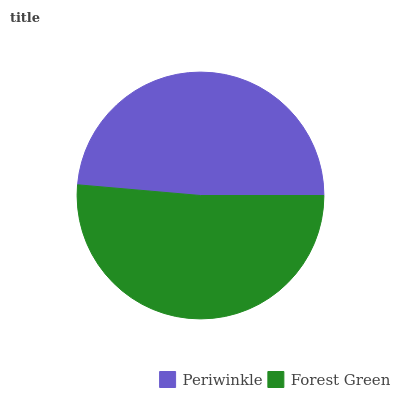Is Periwinkle the minimum?
Answer yes or no. Yes. Is Forest Green the maximum?
Answer yes or no. Yes. Is Forest Green the minimum?
Answer yes or no. No. Is Forest Green greater than Periwinkle?
Answer yes or no. Yes. Is Periwinkle less than Forest Green?
Answer yes or no. Yes. Is Periwinkle greater than Forest Green?
Answer yes or no. No. Is Forest Green less than Periwinkle?
Answer yes or no. No. Is Forest Green the high median?
Answer yes or no. Yes. Is Periwinkle the low median?
Answer yes or no. Yes. Is Periwinkle the high median?
Answer yes or no. No. Is Forest Green the low median?
Answer yes or no. No. 